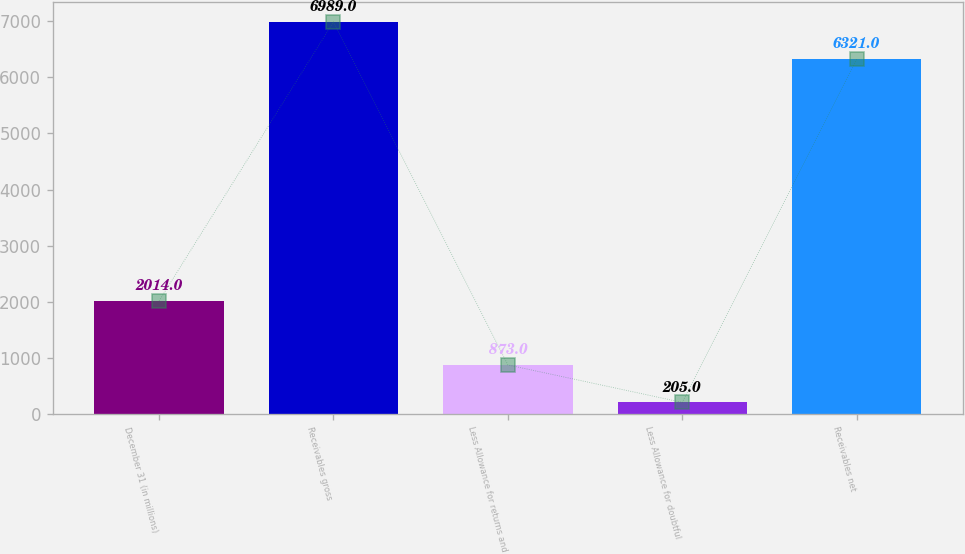<chart> <loc_0><loc_0><loc_500><loc_500><bar_chart><fcel>December 31 (in millions)<fcel>Receivables gross<fcel>Less Allowance for returns and<fcel>Less Allowance for doubtful<fcel>Receivables net<nl><fcel>2014<fcel>6989<fcel>873<fcel>205<fcel>6321<nl></chart> 